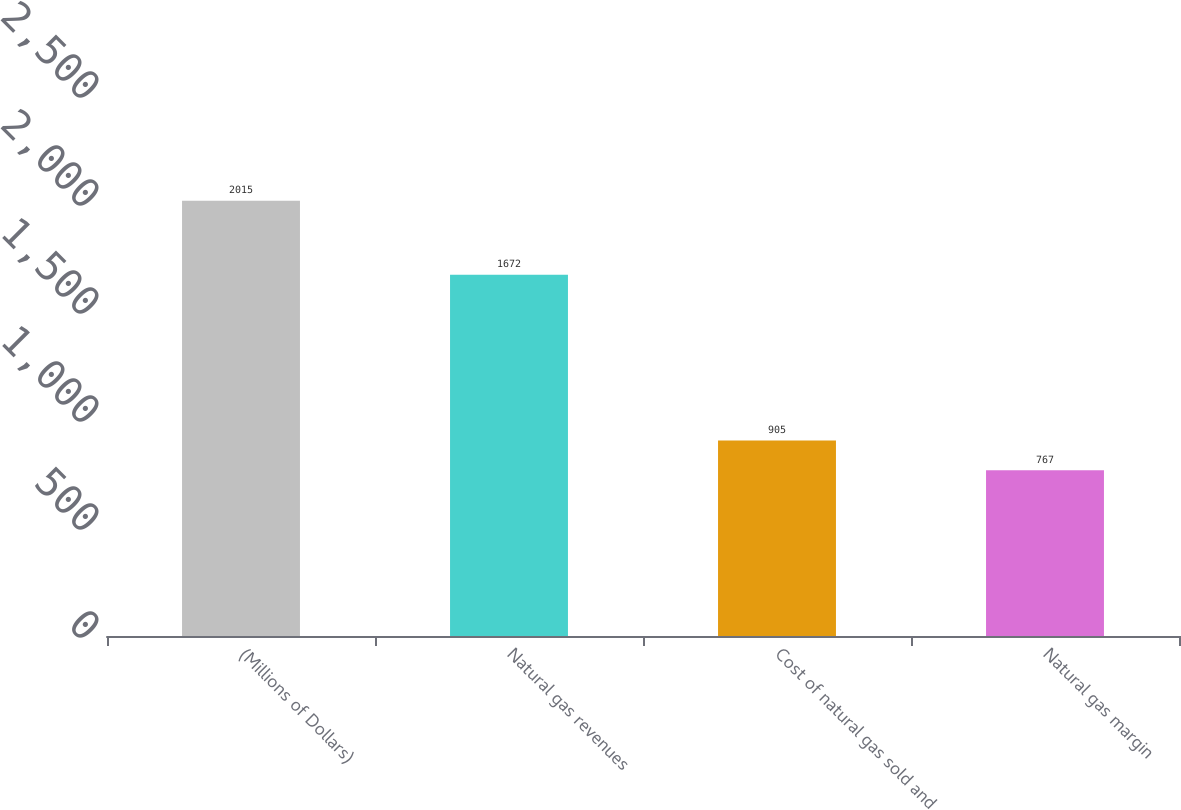Convert chart. <chart><loc_0><loc_0><loc_500><loc_500><bar_chart><fcel>(Millions of Dollars)<fcel>Natural gas revenues<fcel>Cost of natural gas sold and<fcel>Natural gas margin<nl><fcel>2015<fcel>1672<fcel>905<fcel>767<nl></chart> 